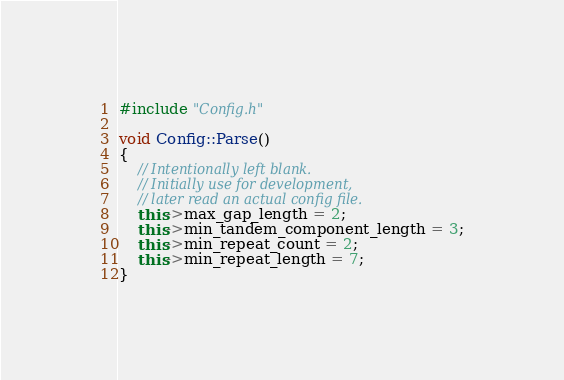<code> <loc_0><loc_0><loc_500><loc_500><_C++_>#include "Config.h"

void Config::Parse()
{
	// Intentionally left blank.
	// Initially use for development,
	// later read an actual config file.
	this->max_gap_length = 2;
	this->min_tandem_component_length = 3;
	this->min_repeat_count = 2;
	this->min_repeat_length = 7;
}</code> 